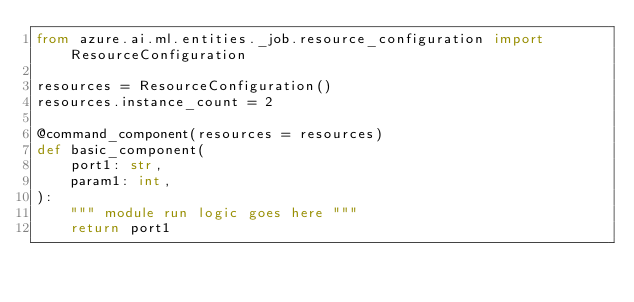<code> <loc_0><loc_0><loc_500><loc_500><_Python_>from azure.ai.ml.entities._job.resource_configuration import ResourceConfiguration

resources = ResourceConfiguration()
resources.instance_count = 2

@command_component(resources = resources)
def basic_component(
    port1: str,
    param1: int,
):
    """ module run logic goes here """
    return port1
</code> 